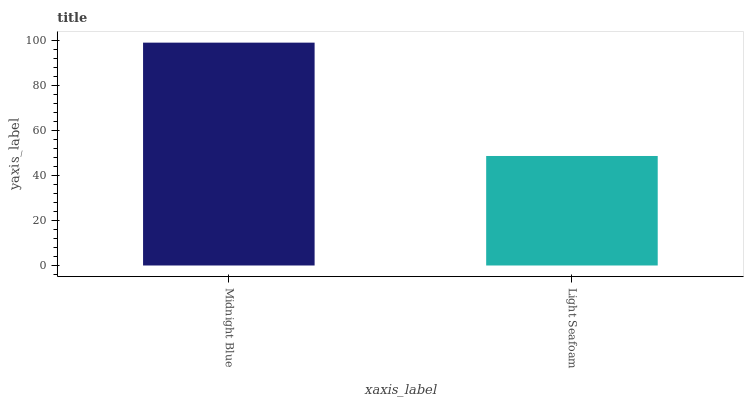Is Light Seafoam the minimum?
Answer yes or no. Yes. Is Midnight Blue the maximum?
Answer yes or no. Yes. Is Light Seafoam the maximum?
Answer yes or no. No. Is Midnight Blue greater than Light Seafoam?
Answer yes or no. Yes. Is Light Seafoam less than Midnight Blue?
Answer yes or no. Yes. Is Light Seafoam greater than Midnight Blue?
Answer yes or no. No. Is Midnight Blue less than Light Seafoam?
Answer yes or no. No. Is Midnight Blue the high median?
Answer yes or no. Yes. Is Light Seafoam the low median?
Answer yes or no. Yes. Is Light Seafoam the high median?
Answer yes or no. No. Is Midnight Blue the low median?
Answer yes or no. No. 